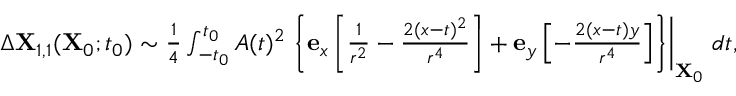<formula> <loc_0><loc_0><loc_500><loc_500>\begin{array} { r } { \Delta X _ { 1 , 1 } ( X _ { 0 } ; t _ { 0 } ) \sim \frac { 1 } { 4 } \int _ { - t _ { 0 } } ^ { t _ { 0 } } A ( t ) ^ { 2 } \left \{ e _ { x } \left [ \frac { 1 } { r ^ { 2 } } - \frac { 2 ( x - t ) ^ { 2 } } { r ^ { 4 } } \right ] + e _ { y } \left [ - \frac { 2 ( x - t ) y } { r ^ { 4 } } \right ] \right \} \right | _ { X _ { 0 } } \, d t , } \end{array}</formula> 